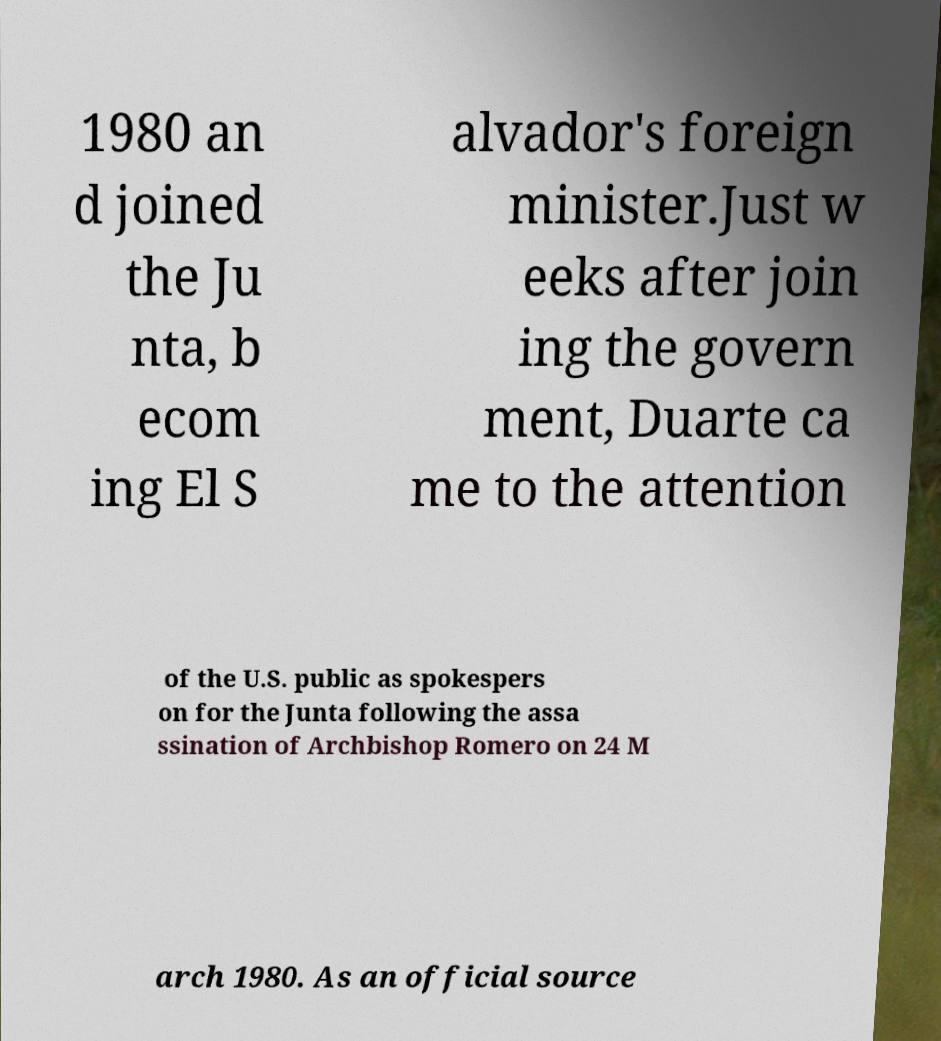There's text embedded in this image that I need extracted. Can you transcribe it verbatim? 1980 an d joined the Ju nta, b ecom ing El S alvador's foreign minister.Just w eeks after join ing the govern ment, Duarte ca me to the attention of the U.S. public as spokespers on for the Junta following the assa ssination of Archbishop Romero on 24 M arch 1980. As an official source 